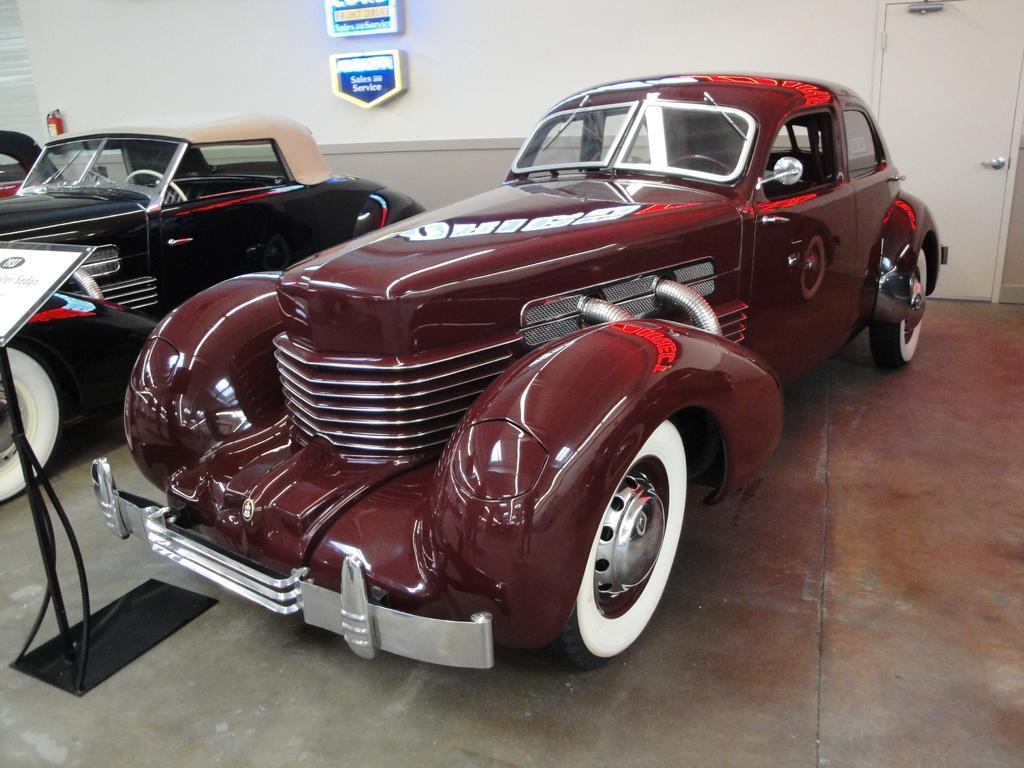In one or two sentences, can you explain what this image depicts? There are cars in the middle of this image. We can see a stand on the left side of this image. There are two boards attached to the wall which is at the top of this image. We can see a door in the top right corner of this image. 